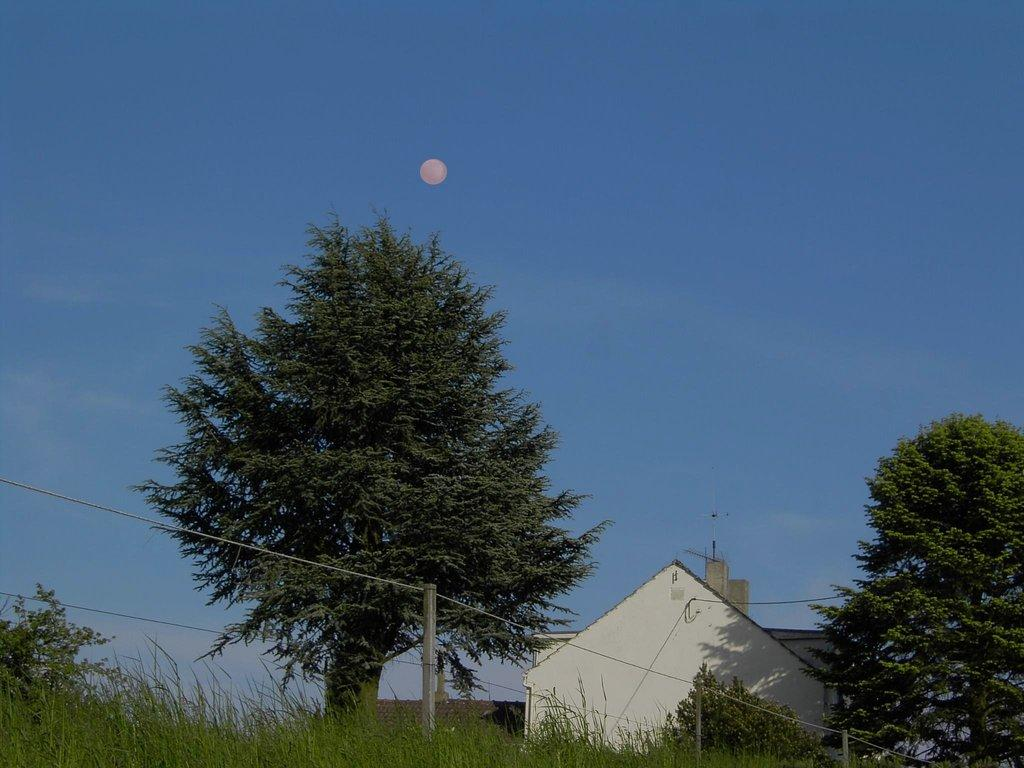What type of vegetation can be seen in the foreground of the image? There is grass, plants, and trees in the foreground of the image. What structures are present in the foreground of the image? There are houses and a fence in the foreground of the image. What can be seen in the background of the image? The sky is visible in the background of the image, and the sun is also visible. Based on the presence of the sun, can we determine the time of day the image was taken? Yes, the image is likely taken during the day. Where can we find the brush used for cleaning the lunchroom in the image? There is no brush or lunchroom present in the image. How many frogs are sitting on the fence in the image? There are no frogs present in the image. 